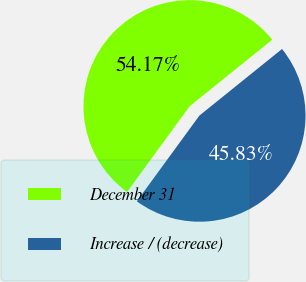Convert chart. <chart><loc_0><loc_0><loc_500><loc_500><pie_chart><fcel>December 31<fcel>Increase / (decrease)<nl><fcel>54.17%<fcel>45.83%<nl></chart> 